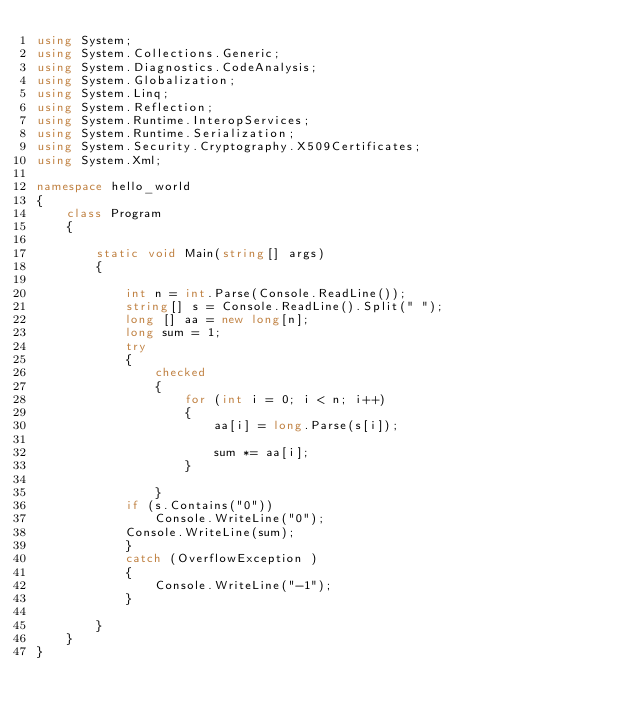<code> <loc_0><loc_0><loc_500><loc_500><_C#_>using System;
using System.Collections.Generic;
using System.Diagnostics.CodeAnalysis;
using System.Globalization;
using System.Linq;
using System.Reflection;
using System.Runtime.InteropServices;
using System.Runtime.Serialization;
using System.Security.Cryptography.X509Certificates;
using System.Xml;

namespace hello_world
{
	class Program
	{

		static void Main(string[] args)
		{

			int n = int.Parse(Console.ReadLine());
			string[] s = Console.ReadLine().Split(" ");
			long [] aa = new long[n];
			long sum = 1;
			try
			{
				checked
				{
					for (int i = 0; i < n; i++)
					{
						aa[i] = long.Parse(s[i]);

						sum *= aa[i];
					}
					
				}
			if (s.Contains("0"))
				Console.WriteLine("0");
			Console.WriteLine(sum);
			}
			catch (OverflowException )
			{
				Console.WriteLine("-1");
			}

		}
	}
}</code> 